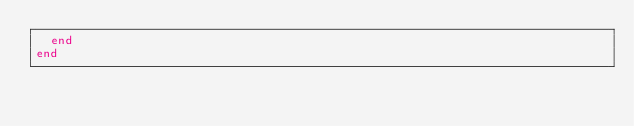<code> <loc_0><loc_0><loc_500><loc_500><_Ruby_>  end
end
</code> 